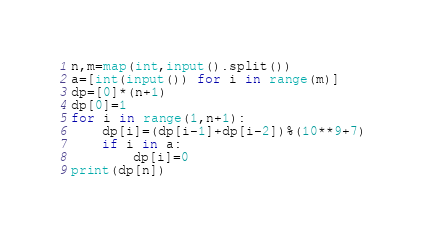<code> <loc_0><loc_0><loc_500><loc_500><_Python_>n,m=map(int,input().split())
a=[int(input()) for i in range(m)]
dp=[0]*(n+1)
dp[0]=1
for i in range(1,n+1):
    dp[i]=(dp[i-1]+dp[i-2])%(10**9+7)
    if i in a:
        dp[i]=0
print(dp[n])</code> 